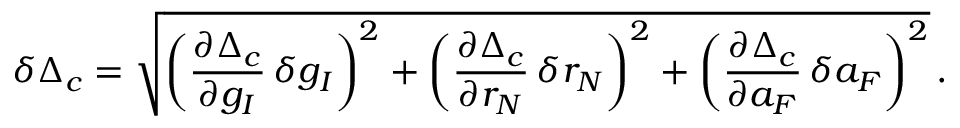Convert formula to latex. <formula><loc_0><loc_0><loc_500><loc_500>\delta \Delta _ { c } = \sqrt { \left ( \frac { \partial \Delta _ { c } } { \partial g _ { I } } \, \delta g _ { I } \right ) ^ { 2 } + \left ( \frac { \partial \Delta _ { c } } { \partial r _ { N } } \, \delta r _ { N } \right ) ^ { 2 } + \left ( \frac { \partial \Delta _ { c } } { \partial a _ { F } } \, \delta a _ { F } \right ) ^ { 2 } } \, .</formula> 